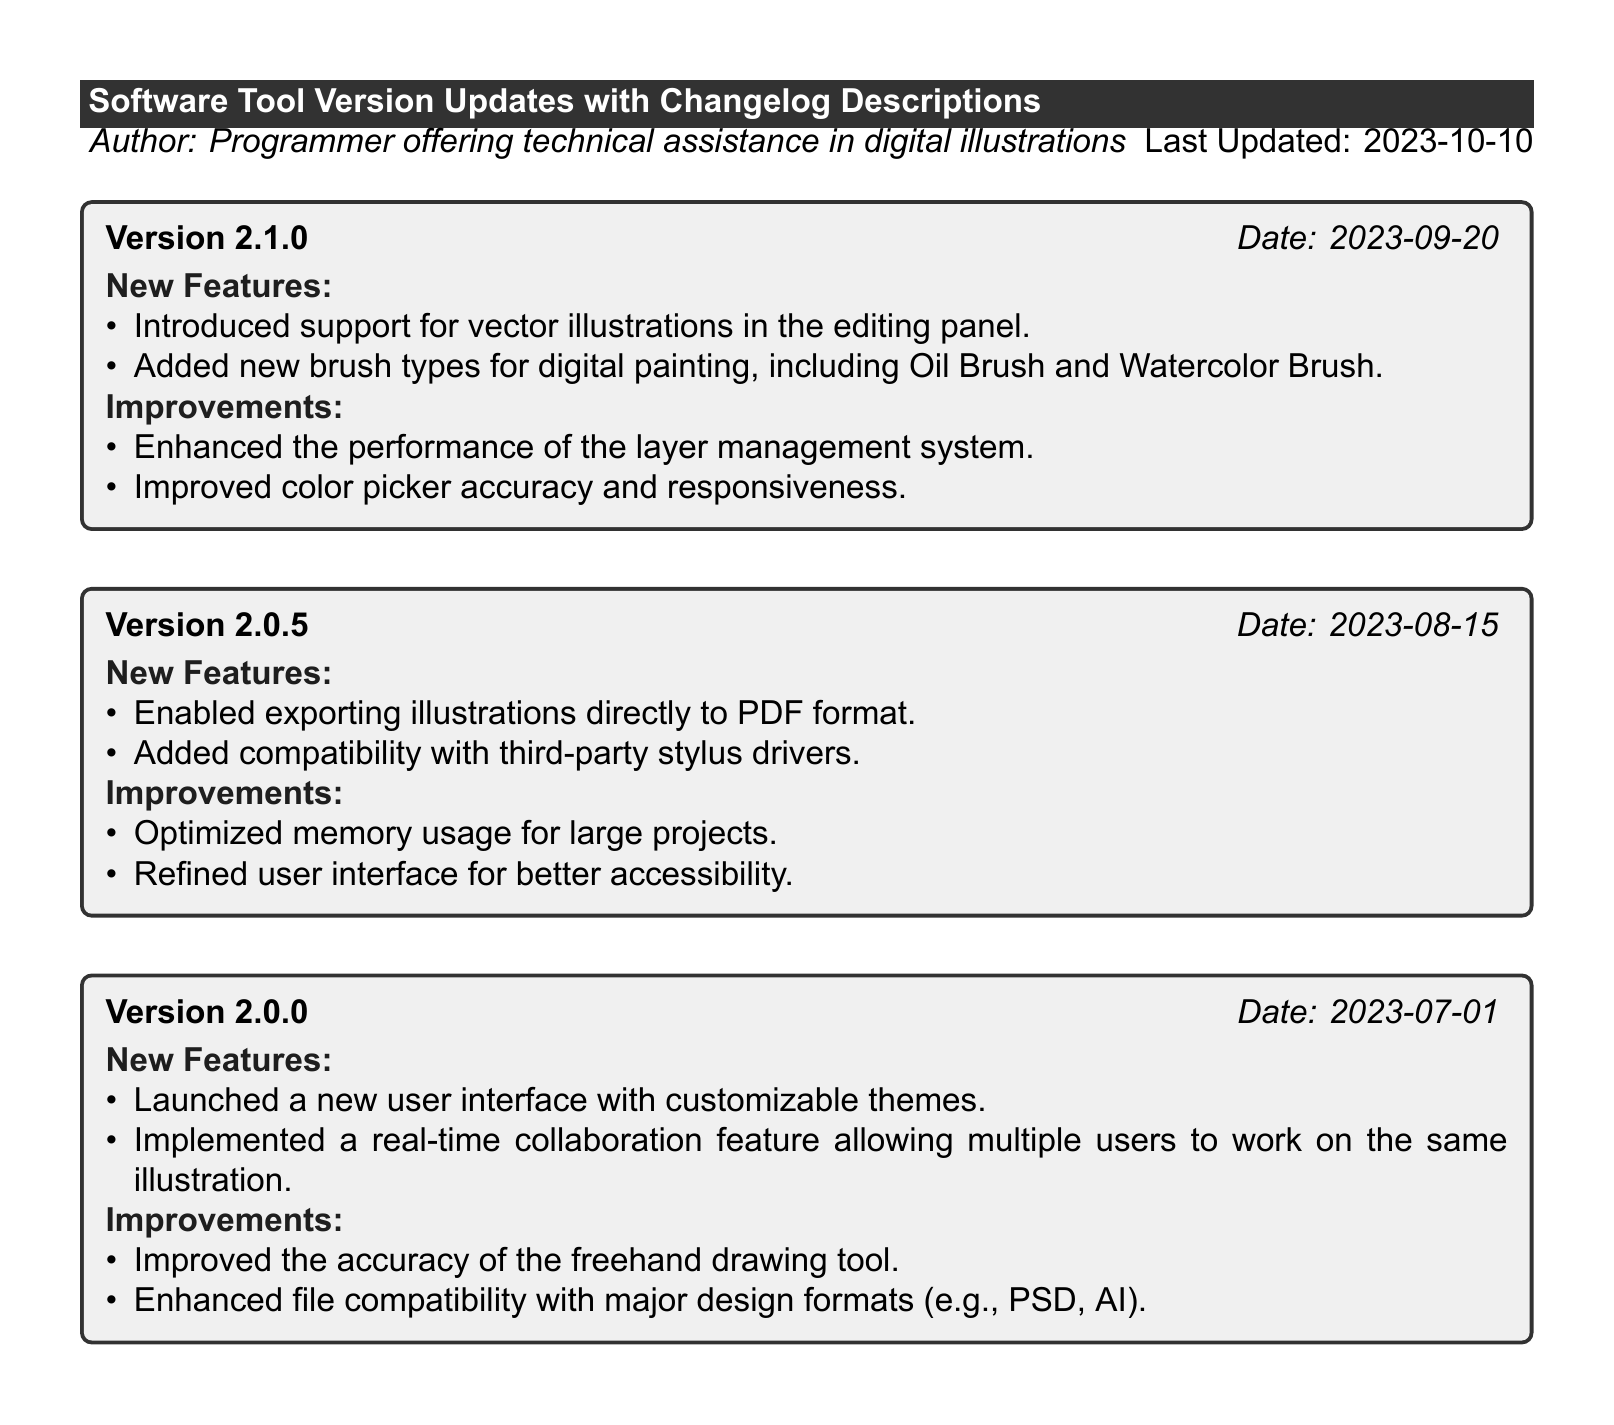What is the latest version of the software tool? The document lists the latest version as version 2.1.0, which is the most recent entry.
Answer: 2.1.0 When was version 2.0.5 released? The document provides the release date for version 2.0.5 as August 15, 2023, indicated in the entry.
Answer: 2023-08-15 What new feature was introduced in version 2.1.0? The entry for version 2.1.0 states that it introduced support for vector illustrations in the editing panel.
Answer: Support for vector illustrations What improvement was made in version 2.0.0? The document mentions that version 2.0.0 enhanced file compatibility with major design formats, listed under improvements.
Answer: Enhanced file compatibility How many new features were added in version 2.0.0? The entry for version 2.0.0 includes two new features, which are both listed in the document.
Answer: 2 Which brush types were added in version 2.1.0? The document specifies that version 2.1.0 added new brush types, including Oil Brush and Watercolor Brush.
Answer: Oil Brush and Watercolor Brush What type of file export was enabled in version 2.0.5? The document outlines that version 2.0.5 allowed exporting illustrations directly to PDF format.
Answer: PDF format What is the primary focus of this document? The document is focused on detailing software tool version updates along with their changelog descriptions.
Answer: Software tool version updates 